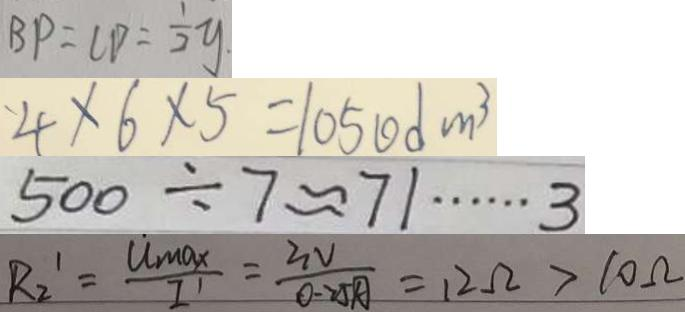Convert formula to latex. <formula><loc_0><loc_0><loc_500><loc_500>B P = C D = \frac { 1 } { 2 } y 
 4 \times 6 \times 5 = 1 0 5 0 d m ^ { 3 } 
 5 0 0 \div 7 \approx 7 1 \cdots 3 
 R _ { 2 } ^ { \prime } = \frac { u _ { \max } } { I ^ { \prime } } = \frac { 3 V } { 0 . 2 5 A } = 1 2 \Omega > 1 0 \Omega</formula> 